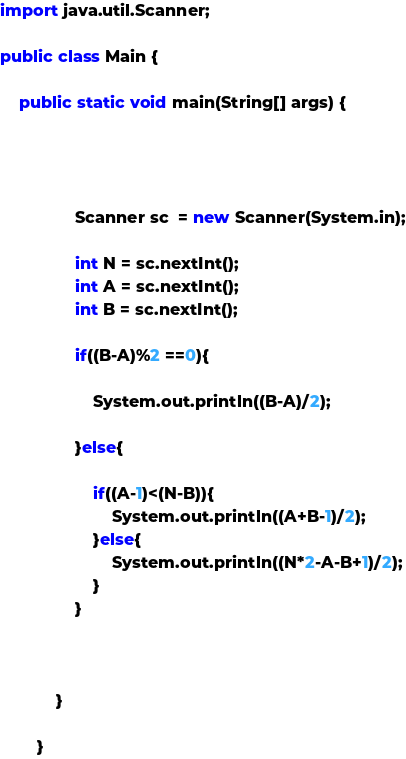<code> <loc_0><loc_0><loc_500><loc_500><_Java_>import java.util.Scanner;

public class Main {

    public static void main(String[] args) {




                Scanner sc  = new Scanner(System.in);

                int N = sc.nextInt();
                int A = sc.nextInt();
                int B = sc.nextInt();

                if((B-A)%2 ==0){

                    System.out.println((B-A)/2);

                }else{

                    if((A-1)<(N-B)){
                        System.out.println((A+B-1)/2);
                    }else{
                        System.out.println((N*2-A-B+1)/2);
                    }
                }



            }

        }
</code> 